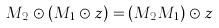Convert formula to latex. <formula><loc_0><loc_0><loc_500><loc_500>M _ { 2 } \odot ( M _ { 1 } \odot z ) = ( M _ { 2 } M _ { 1 } ) \odot z</formula> 